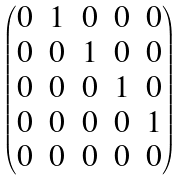Convert formula to latex. <formula><loc_0><loc_0><loc_500><loc_500>\begin{pmatrix} 0 & 1 & 0 & 0 & 0 \\ 0 & 0 & 1 & 0 & 0 \\ 0 & 0 & 0 & 1 & 0 \\ 0 & 0 & 0 & 0 & 1 \\ 0 & 0 & 0 & 0 & 0 \end{pmatrix}</formula> 